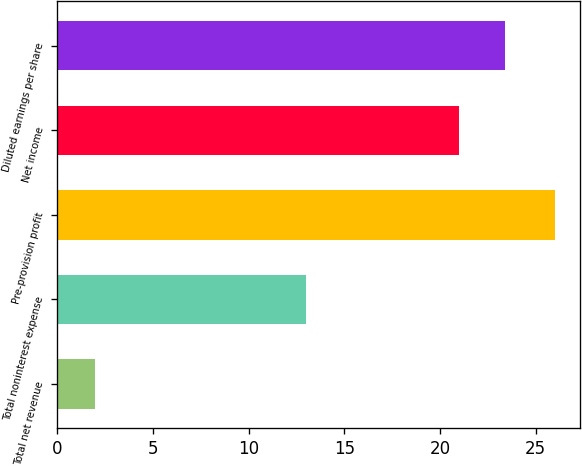<chart> <loc_0><loc_0><loc_500><loc_500><bar_chart><fcel>Total net revenue<fcel>Total noninterest expense<fcel>Pre-provision profit<fcel>Net income<fcel>Diluted earnings per share<nl><fcel>2<fcel>13<fcel>26<fcel>21<fcel>23.4<nl></chart> 